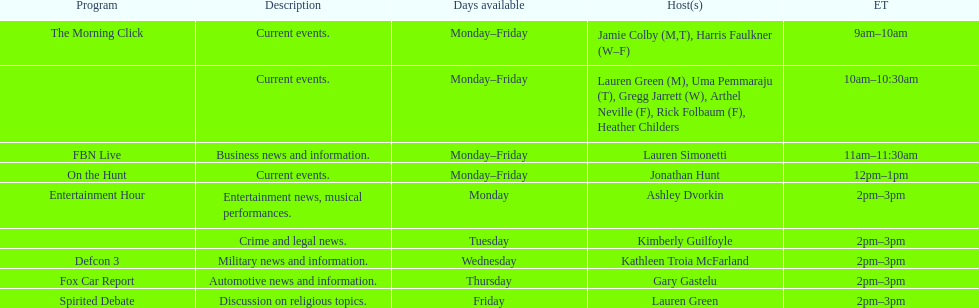Can you parse all the data within this table? {'header': ['Program', 'Description', 'Days available', 'Host(s)', 'ET'], 'rows': [['The Morning Click', 'Current events.', 'Monday–Friday', 'Jamie Colby (M,T), Harris Faulkner (W–F)', '9am–10am'], ['', 'Current events.', 'Monday–Friday', 'Lauren Green (M), Uma Pemmaraju (T), Gregg Jarrett (W), Arthel Neville (F), Rick Folbaum (F), Heather Childers', '10am–10:30am'], ['FBN Live', 'Business news and information.', 'Monday–Friday', 'Lauren Simonetti', '11am–11:30am'], ['On the Hunt', 'Current events.', 'Monday–Friday', 'Jonathan Hunt', '12pm–1pm'], ['Entertainment Hour', 'Entertainment news, musical performances.', 'Monday', 'Ashley Dvorkin', '2pm–3pm'], ['', 'Crime and legal news.', 'Tuesday', 'Kimberly Guilfoyle', '2pm–3pm'], ['Defcon 3', 'Military news and information.', 'Wednesday', 'Kathleen Troia McFarland', '2pm–3pm'], ['Fox Car Report', 'Automotive news and information.', 'Thursday', 'Gary Gastelu', '2pm–3pm'], ['Spirited Debate', 'Discussion on religious topics.', 'Friday', 'Lauren Green', '2pm–3pm']]} Which program is only available on thursdays? Fox Car Report. 